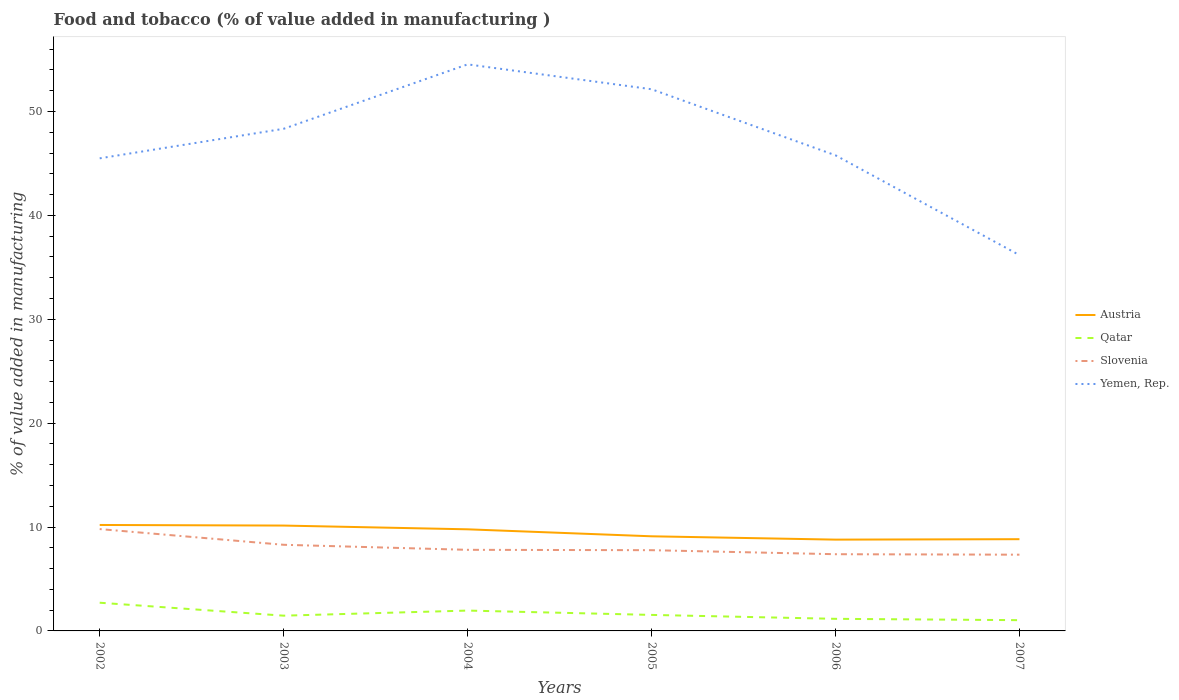How many different coloured lines are there?
Ensure brevity in your answer.  4. Across all years, what is the maximum value added in manufacturing food and tobacco in Yemen, Rep.?
Your answer should be very brief. 36.17. In which year was the value added in manufacturing food and tobacco in Austria maximum?
Make the answer very short. 2006. What is the total value added in manufacturing food and tobacco in Qatar in the graph?
Your response must be concise. 0.51. What is the difference between the highest and the second highest value added in manufacturing food and tobacco in Yemen, Rep.?
Provide a succinct answer. 18.36. Does the graph contain any zero values?
Your answer should be very brief. No. Does the graph contain grids?
Offer a terse response. No. How many legend labels are there?
Your response must be concise. 4. How are the legend labels stacked?
Keep it short and to the point. Vertical. What is the title of the graph?
Give a very brief answer. Food and tobacco (% of value added in manufacturing ). What is the label or title of the Y-axis?
Your answer should be compact. % of value added in manufacturing. What is the % of value added in manufacturing in Austria in 2002?
Offer a very short reply. 10.2. What is the % of value added in manufacturing in Qatar in 2002?
Provide a short and direct response. 2.71. What is the % of value added in manufacturing of Slovenia in 2002?
Make the answer very short. 9.8. What is the % of value added in manufacturing in Yemen, Rep. in 2002?
Ensure brevity in your answer.  45.49. What is the % of value added in manufacturing of Austria in 2003?
Your response must be concise. 10.14. What is the % of value added in manufacturing in Qatar in 2003?
Give a very brief answer. 1.47. What is the % of value added in manufacturing of Slovenia in 2003?
Offer a very short reply. 8.29. What is the % of value added in manufacturing of Yemen, Rep. in 2003?
Make the answer very short. 48.33. What is the % of value added in manufacturing of Austria in 2004?
Provide a short and direct response. 9.78. What is the % of value added in manufacturing of Qatar in 2004?
Keep it short and to the point. 1.96. What is the % of value added in manufacturing of Slovenia in 2004?
Ensure brevity in your answer.  7.81. What is the % of value added in manufacturing in Yemen, Rep. in 2004?
Provide a short and direct response. 54.53. What is the % of value added in manufacturing in Austria in 2005?
Make the answer very short. 9.11. What is the % of value added in manufacturing of Qatar in 2005?
Ensure brevity in your answer.  1.54. What is the % of value added in manufacturing of Slovenia in 2005?
Offer a terse response. 7.77. What is the % of value added in manufacturing in Yemen, Rep. in 2005?
Give a very brief answer. 52.14. What is the % of value added in manufacturing in Austria in 2006?
Your response must be concise. 8.79. What is the % of value added in manufacturing in Qatar in 2006?
Your response must be concise. 1.16. What is the % of value added in manufacturing of Slovenia in 2006?
Provide a short and direct response. 7.38. What is the % of value added in manufacturing of Yemen, Rep. in 2006?
Offer a very short reply. 45.78. What is the % of value added in manufacturing in Austria in 2007?
Give a very brief answer. 8.83. What is the % of value added in manufacturing of Qatar in 2007?
Ensure brevity in your answer.  1.04. What is the % of value added in manufacturing in Slovenia in 2007?
Give a very brief answer. 7.34. What is the % of value added in manufacturing in Yemen, Rep. in 2007?
Make the answer very short. 36.17. Across all years, what is the maximum % of value added in manufacturing in Austria?
Keep it short and to the point. 10.2. Across all years, what is the maximum % of value added in manufacturing of Qatar?
Offer a terse response. 2.71. Across all years, what is the maximum % of value added in manufacturing in Slovenia?
Your response must be concise. 9.8. Across all years, what is the maximum % of value added in manufacturing of Yemen, Rep.?
Provide a short and direct response. 54.53. Across all years, what is the minimum % of value added in manufacturing of Austria?
Your response must be concise. 8.79. Across all years, what is the minimum % of value added in manufacturing of Qatar?
Give a very brief answer. 1.04. Across all years, what is the minimum % of value added in manufacturing in Slovenia?
Your answer should be very brief. 7.34. Across all years, what is the minimum % of value added in manufacturing in Yemen, Rep.?
Provide a succinct answer. 36.17. What is the total % of value added in manufacturing in Austria in the graph?
Your response must be concise. 56.85. What is the total % of value added in manufacturing of Qatar in the graph?
Your answer should be compact. 9.88. What is the total % of value added in manufacturing of Slovenia in the graph?
Provide a succinct answer. 48.39. What is the total % of value added in manufacturing of Yemen, Rep. in the graph?
Offer a terse response. 282.45. What is the difference between the % of value added in manufacturing of Austria in 2002 and that in 2003?
Ensure brevity in your answer.  0.06. What is the difference between the % of value added in manufacturing of Qatar in 2002 and that in 2003?
Offer a very short reply. 1.25. What is the difference between the % of value added in manufacturing of Slovenia in 2002 and that in 2003?
Give a very brief answer. 1.51. What is the difference between the % of value added in manufacturing of Yemen, Rep. in 2002 and that in 2003?
Ensure brevity in your answer.  -2.84. What is the difference between the % of value added in manufacturing in Austria in 2002 and that in 2004?
Your answer should be compact. 0.42. What is the difference between the % of value added in manufacturing of Qatar in 2002 and that in 2004?
Offer a very short reply. 0.76. What is the difference between the % of value added in manufacturing of Slovenia in 2002 and that in 2004?
Provide a succinct answer. 2. What is the difference between the % of value added in manufacturing in Yemen, Rep. in 2002 and that in 2004?
Give a very brief answer. -9.04. What is the difference between the % of value added in manufacturing in Austria in 2002 and that in 2005?
Your answer should be compact. 1.09. What is the difference between the % of value added in manufacturing in Qatar in 2002 and that in 2005?
Offer a terse response. 1.17. What is the difference between the % of value added in manufacturing of Slovenia in 2002 and that in 2005?
Your answer should be very brief. 2.03. What is the difference between the % of value added in manufacturing of Yemen, Rep. in 2002 and that in 2005?
Your answer should be compact. -6.65. What is the difference between the % of value added in manufacturing in Austria in 2002 and that in 2006?
Provide a succinct answer. 1.41. What is the difference between the % of value added in manufacturing in Qatar in 2002 and that in 2006?
Ensure brevity in your answer.  1.55. What is the difference between the % of value added in manufacturing of Slovenia in 2002 and that in 2006?
Your answer should be very brief. 2.42. What is the difference between the % of value added in manufacturing of Yemen, Rep. in 2002 and that in 2006?
Provide a succinct answer. -0.29. What is the difference between the % of value added in manufacturing in Austria in 2002 and that in 2007?
Keep it short and to the point. 1.37. What is the difference between the % of value added in manufacturing in Qatar in 2002 and that in 2007?
Your answer should be compact. 1.68. What is the difference between the % of value added in manufacturing in Slovenia in 2002 and that in 2007?
Keep it short and to the point. 2.46. What is the difference between the % of value added in manufacturing in Yemen, Rep. in 2002 and that in 2007?
Your answer should be very brief. 9.32. What is the difference between the % of value added in manufacturing of Austria in 2003 and that in 2004?
Provide a succinct answer. 0.36. What is the difference between the % of value added in manufacturing of Qatar in 2003 and that in 2004?
Keep it short and to the point. -0.49. What is the difference between the % of value added in manufacturing of Slovenia in 2003 and that in 2004?
Ensure brevity in your answer.  0.48. What is the difference between the % of value added in manufacturing in Yemen, Rep. in 2003 and that in 2004?
Your answer should be very brief. -6.2. What is the difference between the % of value added in manufacturing of Austria in 2003 and that in 2005?
Your answer should be compact. 1.03. What is the difference between the % of value added in manufacturing of Qatar in 2003 and that in 2005?
Ensure brevity in your answer.  -0.07. What is the difference between the % of value added in manufacturing of Slovenia in 2003 and that in 2005?
Provide a short and direct response. 0.52. What is the difference between the % of value added in manufacturing in Yemen, Rep. in 2003 and that in 2005?
Provide a short and direct response. -3.81. What is the difference between the % of value added in manufacturing in Austria in 2003 and that in 2006?
Give a very brief answer. 1.35. What is the difference between the % of value added in manufacturing in Qatar in 2003 and that in 2006?
Your response must be concise. 0.3. What is the difference between the % of value added in manufacturing of Slovenia in 2003 and that in 2006?
Give a very brief answer. 0.91. What is the difference between the % of value added in manufacturing of Yemen, Rep. in 2003 and that in 2006?
Provide a short and direct response. 2.55. What is the difference between the % of value added in manufacturing in Austria in 2003 and that in 2007?
Provide a succinct answer. 1.31. What is the difference between the % of value added in manufacturing in Qatar in 2003 and that in 2007?
Your response must be concise. 0.43. What is the difference between the % of value added in manufacturing of Slovenia in 2003 and that in 2007?
Offer a very short reply. 0.95. What is the difference between the % of value added in manufacturing in Yemen, Rep. in 2003 and that in 2007?
Your response must be concise. 12.16. What is the difference between the % of value added in manufacturing of Austria in 2004 and that in 2005?
Keep it short and to the point. 0.67. What is the difference between the % of value added in manufacturing in Qatar in 2004 and that in 2005?
Make the answer very short. 0.42. What is the difference between the % of value added in manufacturing in Slovenia in 2004 and that in 2005?
Provide a short and direct response. 0.03. What is the difference between the % of value added in manufacturing in Yemen, Rep. in 2004 and that in 2005?
Your answer should be very brief. 2.39. What is the difference between the % of value added in manufacturing in Austria in 2004 and that in 2006?
Your answer should be compact. 0.99. What is the difference between the % of value added in manufacturing in Qatar in 2004 and that in 2006?
Make the answer very short. 0.79. What is the difference between the % of value added in manufacturing of Slovenia in 2004 and that in 2006?
Provide a succinct answer. 0.42. What is the difference between the % of value added in manufacturing in Yemen, Rep. in 2004 and that in 2006?
Ensure brevity in your answer.  8.75. What is the difference between the % of value added in manufacturing in Austria in 2004 and that in 2007?
Your answer should be compact. 0.95. What is the difference between the % of value added in manufacturing in Qatar in 2004 and that in 2007?
Offer a very short reply. 0.92. What is the difference between the % of value added in manufacturing of Slovenia in 2004 and that in 2007?
Your answer should be very brief. 0.47. What is the difference between the % of value added in manufacturing in Yemen, Rep. in 2004 and that in 2007?
Your answer should be very brief. 18.36. What is the difference between the % of value added in manufacturing in Austria in 2005 and that in 2006?
Your response must be concise. 0.32. What is the difference between the % of value added in manufacturing of Qatar in 2005 and that in 2006?
Offer a very short reply. 0.38. What is the difference between the % of value added in manufacturing in Slovenia in 2005 and that in 2006?
Your response must be concise. 0.39. What is the difference between the % of value added in manufacturing of Yemen, Rep. in 2005 and that in 2006?
Make the answer very short. 6.36. What is the difference between the % of value added in manufacturing of Austria in 2005 and that in 2007?
Keep it short and to the point. 0.28. What is the difference between the % of value added in manufacturing in Qatar in 2005 and that in 2007?
Your answer should be very brief. 0.51. What is the difference between the % of value added in manufacturing of Slovenia in 2005 and that in 2007?
Give a very brief answer. 0.43. What is the difference between the % of value added in manufacturing in Yemen, Rep. in 2005 and that in 2007?
Ensure brevity in your answer.  15.97. What is the difference between the % of value added in manufacturing of Austria in 2006 and that in 2007?
Offer a terse response. -0.04. What is the difference between the % of value added in manufacturing of Qatar in 2006 and that in 2007?
Your answer should be compact. 0.13. What is the difference between the % of value added in manufacturing in Slovenia in 2006 and that in 2007?
Keep it short and to the point. 0.05. What is the difference between the % of value added in manufacturing in Yemen, Rep. in 2006 and that in 2007?
Keep it short and to the point. 9.61. What is the difference between the % of value added in manufacturing in Austria in 2002 and the % of value added in manufacturing in Qatar in 2003?
Ensure brevity in your answer.  8.73. What is the difference between the % of value added in manufacturing in Austria in 2002 and the % of value added in manufacturing in Slovenia in 2003?
Your response must be concise. 1.91. What is the difference between the % of value added in manufacturing of Austria in 2002 and the % of value added in manufacturing of Yemen, Rep. in 2003?
Provide a short and direct response. -38.14. What is the difference between the % of value added in manufacturing of Qatar in 2002 and the % of value added in manufacturing of Slovenia in 2003?
Your answer should be very brief. -5.58. What is the difference between the % of value added in manufacturing of Qatar in 2002 and the % of value added in manufacturing of Yemen, Rep. in 2003?
Offer a terse response. -45.62. What is the difference between the % of value added in manufacturing of Slovenia in 2002 and the % of value added in manufacturing of Yemen, Rep. in 2003?
Give a very brief answer. -38.53. What is the difference between the % of value added in manufacturing in Austria in 2002 and the % of value added in manufacturing in Qatar in 2004?
Provide a short and direct response. 8.24. What is the difference between the % of value added in manufacturing in Austria in 2002 and the % of value added in manufacturing in Slovenia in 2004?
Your answer should be very brief. 2.39. What is the difference between the % of value added in manufacturing of Austria in 2002 and the % of value added in manufacturing of Yemen, Rep. in 2004?
Provide a short and direct response. -44.34. What is the difference between the % of value added in manufacturing of Qatar in 2002 and the % of value added in manufacturing of Slovenia in 2004?
Offer a very short reply. -5.09. What is the difference between the % of value added in manufacturing of Qatar in 2002 and the % of value added in manufacturing of Yemen, Rep. in 2004?
Provide a short and direct response. -51.82. What is the difference between the % of value added in manufacturing in Slovenia in 2002 and the % of value added in manufacturing in Yemen, Rep. in 2004?
Provide a succinct answer. -44.73. What is the difference between the % of value added in manufacturing in Austria in 2002 and the % of value added in manufacturing in Qatar in 2005?
Your answer should be compact. 8.66. What is the difference between the % of value added in manufacturing in Austria in 2002 and the % of value added in manufacturing in Slovenia in 2005?
Offer a terse response. 2.43. What is the difference between the % of value added in manufacturing of Austria in 2002 and the % of value added in manufacturing of Yemen, Rep. in 2005?
Offer a very short reply. -41.94. What is the difference between the % of value added in manufacturing of Qatar in 2002 and the % of value added in manufacturing of Slovenia in 2005?
Offer a terse response. -5.06. What is the difference between the % of value added in manufacturing of Qatar in 2002 and the % of value added in manufacturing of Yemen, Rep. in 2005?
Give a very brief answer. -49.43. What is the difference between the % of value added in manufacturing of Slovenia in 2002 and the % of value added in manufacturing of Yemen, Rep. in 2005?
Ensure brevity in your answer.  -42.34. What is the difference between the % of value added in manufacturing in Austria in 2002 and the % of value added in manufacturing in Qatar in 2006?
Your answer should be compact. 9.03. What is the difference between the % of value added in manufacturing in Austria in 2002 and the % of value added in manufacturing in Slovenia in 2006?
Offer a very short reply. 2.81. What is the difference between the % of value added in manufacturing in Austria in 2002 and the % of value added in manufacturing in Yemen, Rep. in 2006?
Provide a short and direct response. -35.58. What is the difference between the % of value added in manufacturing in Qatar in 2002 and the % of value added in manufacturing in Slovenia in 2006?
Keep it short and to the point. -4.67. What is the difference between the % of value added in manufacturing of Qatar in 2002 and the % of value added in manufacturing of Yemen, Rep. in 2006?
Your response must be concise. -43.07. What is the difference between the % of value added in manufacturing in Slovenia in 2002 and the % of value added in manufacturing in Yemen, Rep. in 2006?
Provide a short and direct response. -35.98. What is the difference between the % of value added in manufacturing in Austria in 2002 and the % of value added in manufacturing in Qatar in 2007?
Keep it short and to the point. 9.16. What is the difference between the % of value added in manufacturing of Austria in 2002 and the % of value added in manufacturing of Slovenia in 2007?
Provide a succinct answer. 2.86. What is the difference between the % of value added in manufacturing in Austria in 2002 and the % of value added in manufacturing in Yemen, Rep. in 2007?
Ensure brevity in your answer.  -25.98. What is the difference between the % of value added in manufacturing in Qatar in 2002 and the % of value added in manufacturing in Slovenia in 2007?
Your response must be concise. -4.62. What is the difference between the % of value added in manufacturing in Qatar in 2002 and the % of value added in manufacturing in Yemen, Rep. in 2007?
Ensure brevity in your answer.  -33.46. What is the difference between the % of value added in manufacturing of Slovenia in 2002 and the % of value added in manufacturing of Yemen, Rep. in 2007?
Your answer should be compact. -26.37. What is the difference between the % of value added in manufacturing in Austria in 2003 and the % of value added in manufacturing in Qatar in 2004?
Make the answer very short. 8.18. What is the difference between the % of value added in manufacturing in Austria in 2003 and the % of value added in manufacturing in Slovenia in 2004?
Give a very brief answer. 2.33. What is the difference between the % of value added in manufacturing in Austria in 2003 and the % of value added in manufacturing in Yemen, Rep. in 2004?
Keep it short and to the point. -44.39. What is the difference between the % of value added in manufacturing of Qatar in 2003 and the % of value added in manufacturing of Slovenia in 2004?
Give a very brief answer. -6.34. What is the difference between the % of value added in manufacturing of Qatar in 2003 and the % of value added in manufacturing of Yemen, Rep. in 2004?
Your answer should be very brief. -53.07. What is the difference between the % of value added in manufacturing of Slovenia in 2003 and the % of value added in manufacturing of Yemen, Rep. in 2004?
Your answer should be compact. -46.24. What is the difference between the % of value added in manufacturing in Austria in 2003 and the % of value added in manufacturing in Qatar in 2005?
Provide a succinct answer. 8.6. What is the difference between the % of value added in manufacturing in Austria in 2003 and the % of value added in manufacturing in Slovenia in 2005?
Your answer should be very brief. 2.37. What is the difference between the % of value added in manufacturing of Austria in 2003 and the % of value added in manufacturing of Yemen, Rep. in 2005?
Give a very brief answer. -42. What is the difference between the % of value added in manufacturing in Qatar in 2003 and the % of value added in manufacturing in Slovenia in 2005?
Make the answer very short. -6.3. What is the difference between the % of value added in manufacturing of Qatar in 2003 and the % of value added in manufacturing of Yemen, Rep. in 2005?
Offer a terse response. -50.67. What is the difference between the % of value added in manufacturing in Slovenia in 2003 and the % of value added in manufacturing in Yemen, Rep. in 2005?
Make the answer very short. -43.85. What is the difference between the % of value added in manufacturing of Austria in 2003 and the % of value added in manufacturing of Qatar in 2006?
Your answer should be compact. 8.98. What is the difference between the % of value added in manufacturing in Austria in 2003 and the % of value added in manufacturing in Slovenia in 2006?
Keep it short and to the point. 2.76. What is the difference between the % of value added in manufacturing in Austria in 2003 and the % of value added in manufacturing in Yemen, Rep. in 2006?
Provide a short and direct response. -35.64. What is the difference between the % of value added in manufacturing in Qatar in 2003 and the % of value added in manufacturing in Slovenia in 2006?
Give a very brief answer. -5.92. What is the difference between the % of value added in manufacturing of Qatar in 2003 and the % of value added in manufacturing of Yemen, Rep. in 2006?
Your answer should be compact. -44.31. What is the difference between the % of value added in manufacturing in Slovenia in 2003 and the % of value added in manufacturing in Yemen, Rep. in 2006?
Keep it short and to the point. -37.49. What is the difference between the % of value added in manufacturing of Austria in 2003 and the % of value added in manufacturing of Qatar in 2007?
Offer a terse response. 9.11. What is the difference between the % of value added in manufacturing in Austria in 2003 and the % of value added in manufacturing in Slovenia in 2007?
Your response must be concise. 2.8. What is the difference between the % of value added in manufacturing of Austria in 2003 and the % of value added in manufacturing of Yemen, Rep. in 2007?
Your answer should be compact. -26.03. What is the difference between the % of value added in manufacturing in Qatar in 2003 and the % of value added in manufacturing in Slovenia in 2007?
Provide a succinct answer. -5.87. What is the difference between the % of value added in manufacturing of Qatar in 2003 and the % of value added in manufacturing of Yemen, Rep. in 2007?
Your answer should be very brief. -34.71. What is the difference between the % of value added in manufacturing of Slovenia in 2003 and the % of value added in manufacturing of Yemen, Rep. in 2007?
Your answer should be compact. -27.88. What is the difference between the % of value added in manufacturing in Austria in 2004 and the % of value added in manufacturing in Qatar in 2005?
Give a very brief answer. 8.24. What is the difference between the % of value added in manufacturing of Austria in 2004 and the % of value added in manufacturing of Slovenia in 2005?
Keep it short and to the point. 2.01. What is the difference between the % of value added in manufacturing of Austria in 2004 and the % of value added in manufacturing of Yemen, Rep. in 2005?
Offer a terse response. -42.36. What is the difference between the % of value added in manufacturing in Qatar in 2004 and the % of value added in manufacturing in Slovenia in 2005?
Your response must be concise. -5.81. What is the difference between the % of value added in manufacturing in Qatar in 2004 and the % of value added in manufacturing in Yemen, Rep. in 2005?
Ensure brevity in your answer.  -50.18. What is the difference between the % of value added in manufacturing of Slovenia in 2004 and the % of value added in manufacturing of Yemen, Rep. in 2005?
Provide a succinct answer. -44.33. What is the difference between the % of value added in manufacturing of Austria in 2004 and the % of value added in manufacturing of Qatar in 2006?
Your answer should be compact. 8.62. What is the difference between the % of value added in manufacturing of Austria in 2004 and the % of value added in manufacturing of Slovenia in 2006?
Offer a terse response. 2.4. What is the difference between the % of value added in manufacturing in Austria in 2004 and the % of value added in manufacturing in Yemen, Rep. in 2006?
Your answer should be compact. -36. What is the difference between the % of value added in manufacturing of Qatar in 2004 and the % of value added in manufacturing of Slovenia in 2006?
Your response must be concise. -5.43. What is the difference between the % of value added in manufacturing in Qatar in 2004 and the % of value added in manufacturing in Yemen, Rep. in 2006?
Give a very brief answer. -43.82. What is the difference between the % of value added in manufacturing of Slovenia in 2004 and the % of value added in manufacturing of Yemen, Rep. in 2006?
Your response must be concise. -37.98. What is the difference between the % of value added in manufacturing in Austria in 2004 and the % of value added in manufacturing in Qatar in 2007?
Your answer should be compact. 8.75. What is the difference between the % of value added in manufacturing in Austria in 2004 and the % of value added in manufacturing in Slovenia in 2007?
Your answer should be compact. 2.44. What is the difference between the % of value added in manufacturing of Austria in 2004 and the % of value added in manufacturing of Yemen, Rep. in 2007?
Provide a succinct answer. -26.39. What is the difference between the % of value added in manufacturing in Qatar in 2004 and the % of value added in manufacturing in Slovenia in 2007?
Provide a succinct answer. -5.38. What is the difference between the % of value added in manufacturing of Qatar in 2004 and the % of value added in manufacturing of Yemen, Rep. in 2007?
Provide a short and direct response. -34.22. What is the difference between the % of value added in manufacturing in Slovenia in 2004 and the % of value added in manufacturing in Yemen, Rep. in 2007?
Your answer should be very brief. -28.37. What is the difference between the % of value added in manufacturing of Austria in 2005 and the % of value added in manufacturing of Qatar in 2006?
Make the answer very short. 7.94. What is the difference between the % of value added in manufacturing of Austria in 2005 and the % of value added in manufacturing of Slovenia in 2006?
Your answer should be very brief. 1.72. What is the difference between the % of value added in manufacturing in Austria in 2005 and the % of value added in manufacturing in Yemen, Rep. in 2006?
Give a very brief answer. -36.67. What is the difference between the % of value added in manufacturing in Qatar in 2005 and the % of value added in manufacturing in Slovenia in 2006?
Provide a succinct answer. -5.84. What is the difference between the % of value added in manufacturing of Qatar in 2005 and the % of value added in manufacturing of Yemen, Rep. in 2006?
Your answer should be very brief. -44.24. What is the difference between the % of value added in manufacturing of Slovenia in 2005 and the % of value added in manufacturing of Yemen, Rep. in 2006?
Your answer should be compact. -38.01. What is the difference between the % of value added in manufacturing in Austria in 2005 and the % of value added in manufacturing in Qatar in 2007?
Ensure brevity in your answer.  8.07. What is the difference between the % of value added in manufacturing of Austria in 2005 and the % of value added in manufacturing of Slovenia in 2007?
Provide a succinct answer. 1.77. What is the difference between the % of value added in manufacturing of Austria in 2005 and the % of value added in manufacturing of Yemen, Rep. in 2007?
Give a very brief answer. -27.07. What is the difference between the % of value added in manufacturing of Qatar in 2005 and the % of value added in manufacturing of Slovenia in 2007?
Offer a terse response. -5.8. What is the difference between the % of value added in manufacturing of Qatar in 2005 and the % of value added in manufacturing of Yemen, Rep. in 2007?
Make the answer very short. -34.63. What is the difference between the % of value added in manufacturing of Slovenia in 2005 and the % of value added in manufacturing of Yemen, Rep. in 2007?
Ensure brevity in your answer.  -28.4. What is the difference between the % of value added in manufacturing of Austria in 2006 and the % of value added in manufacturing of Qatar in 2007?
Your answer should be very brief. 7.75. What is the difference between the % of value added in manufacturing of Austria in 2006 and the % of value added in manufacturing of Slovenia in 2007?
Make the answer very short. 1.45. What is the difference between the % of value added in manufacturing in Austria in 2006 and the % of value added in manufacturing in Yemen, Rep. in 2007?
Provide a succinct answer. -27.39. What is the difference between the % of value added in manufacturing of Qatar in 2006 and the % of value added in manufacturing of Slovenia in 2007?
Ensure brevity in your answer.  -6.17. What is the difference between the % of value added in manufacturing in Qatar in 2006 and the % of value added in manufacturing in Yemen, Rep. in 2007?
Keep it short and to the point. -35.01. What is the difference between the % of value added in manufacturing of Slovenia in 2006 and the % of value added in manufacturing of Yemen, Rep. in 2007?
Offer a very short reply. -28.79. What is the average % of value added in manufacturing in Austria per year?
Offer a very short reply. 9.47. What is the average % of value added in manufacturing of Qatar per year?
Provide a succinct answer. 1.65. What is the average % of value added in manufacturing of Slovenia per year?
Keep it short and to the point. 8.07. What is the average % of value added in manufacturing of Yemen, Rep. per year?
Your answer should be compact. 47.08. In the year 2002, what is the difference between the % of value added in manufacturing in Austria and % of value added in manufacturing in Qatar?
Give a very brief answer. 7.48. In the year 2002, what is the difference between the % of value added in manufacturing of Austria and % of value added in manufacturing of Slovenia?
Offer a terse response. 0.39. In the year 2002, what is the difference between the % of value added in manufacturing of Austria and % of value added in manufacturing of Yemen, Rep.?
Give a very brief answer. -35.29. In the year 2002, what is the difference between the % of value added in manufacturing of Qatar and % of value added in manufacturing of Slovenia?
Offer a terse response. -7.09. In the year 2002, what is the difference between the % of value added in manufacturing of Qatar and % of value added in manufacturing of Yemen, Rep.?
Keep it short and to the point. -42.78. In the year 2002, what is the difference between the % of value added in manufacturing of Slovenia and % of value added in manufacturing of Yemen, Rep.?
Make the answer very short. -35.69. In the year 2003, what is the difference between the % of value added in manufacturing of Austria and % of value added in manufacturing of Qatar?
Keep it short and to the point. 8.67. In the year 2003, what is the difference between the % of value added in manufacturing in Austria and % of value added in manufacturing in Slovenia?
Offer a terse response. 1.85. In the year 2003, what is the difference between the % of value added in manufacturing in Austria and % of value added in manufacturing in Yemen, Rep.?
Your answer should be compact. -38.19. In the year 2003, what is the difference between the % of value added in manufacturing of Qatar and % of value added in manufacturing of Slovenia?
Your answer should be very brief. -6.82. In the year 2003, what is the difference between the % of value added in manufacturing of Qatar and % of value added in manufacturing of Yemen, Rep.?
Provide a succinct answer. -46.87. In the year 2003, what is the difference between the % of value added in manufacturing in Slovenia and % of value added in manufacturing in Yemen, Rep.?
Make the answer very short. -40.04. In the year 2004, what is the difference between the % of value added in manufacturing in Austria and % of value added in manufacturing in Qatar?
Your answer should be compact. 7.82. In the year 2004, what is the difference between the % of value added in manufacturing of Austria and % of value added in manufacturing of Slovenia?
Your answer should be compact. 1.97. In the year 2004, what is the difference between the % of value added in manufacturing of Austria and % of value added in manufacturing of Yemen, Rep.?
Provide a short and direct response. -44.75. In the year 2004, what is the difference between the % of value added in manufacturing in Qatar and % of value added in manufacturing in Slovenia?
Your answer should be compact. -5.85. In the year 2004, what is the difference between the % of value added in manufacturing of Qatar and % of value added in manufacturing of Yemen, Rep.?
Give a very brief answer. -52.58. In the year 2004, what is the difference between the % of value added in manufacturing of Slovenia and % of value added in manufacturing of Yemen, Rep.?
Provide a succinct answer. -46.73. In the year 2005, what is the difference between the % of value added in manufacturing of Austria and % of value added in manufacturing of Qatar?
Ensure brevity in your answer.  7.57. In the year 2005, what is the difference between the % of value added in manufacturing in Austria and % of value added in manufacturing in Slovenia?
Your response must be concise. 1.34. In the year 2005, what is the difference between the % of value added in manufacturing in Austria and % of value added in manufacturing in Yemen, Rep.?
Your answer should be compact. -43.03. In the year 2005, what is the difference between the % of value added in manufacturing in Qatar and % of value added in manufacturing in Slovenia?
Offer a terse response. -6.23. In the year 2005, what is the difference between the % of value added in manufacturing of Qatar and % of value added in manufacturing of Yemen, Rep.?
Offer a terse response. -50.6. In the year 2005, what is the difference between the % of value added in manufacturing of Slovenia and % of value added in manufacturing of Yemen, Rep.?
Offer a terse response. -44.37. In the year 2006, what is the difference between the % of value added in manufacturing of Austria and % of value added in manufacturing of Qatar?
Provide a short and direct response. 7.62. In the year 2006, what is the difference between the % of value added in manufacturing in Austria and % of value added in manufacturing in Slovenia?
Offer a very short reply. 1.4. In the year 2006, what is the difference between the % of value added in manufacturing of Austria and % of value added in manufacturing of Yemen, Rep.?
Provide a short and direct response. -36.99. In the year 2006, what is the difference between the % of value added in manufacturing of Qatar and % of value added in manufacturing of Slovenia?
Give a very brief answer. -6.22. In the year 2006, what is the difference between the % of value added in manufacturing of Qatar and % of value added in manufacturing of Yemen, Rep.?
Provide a short and direct response. -44.62. In the year 2006, what is the difference between the % of value added in manufacturing of Slovenia and % of value added in manufacturing of Yemen, Rep.?
Keep it short and to the point. -38.4. In the year 2007, what is the difference between the % of value added in manufacturing in Austria and % of value added in manufacturing in Qatar?
Keep it short and to the point. 7.8. In the year 2007, what is the difference between the % of value added in manufacturing of Austria and % of value added in manufacturing of Slovenia?
Ensure brevity in your answer.  1.49. In the year 2007, what is the difference between the % of value added in manufacturing of Austria and % of value added in manufacturing of Yemen, Rep.?
Make the answer very short. -27.34. In the year 2007, what is the difference between the % of value added in manufacturing in Qatar and % of value added in manufacturing in Slovenia?
Provide a succinct answer. -6.3. In the year 2007, what is the difference between the % of value added in manufacturing in Qatar and % of value added in manufacturing in Yemen, Rep.?
Ensure brevity in your answer.  -35.14. In the year 2007, what is the difference between the % of value added in manufacturing in Slovenia and % of value added in manufacturing in Yemen, Rep.?
Keep it short and to the point. -28.84. What is the ratio of the % of value added in manufacturing of Austria in 2002 to that in 2003?
Your answer should be compact. 1.01. What is the ratio of the % of value added in manufacturing of Qatar in 2002 to that in 2003?
Offer a terse response. 1.85. What is the ratio of the % of value added in manufacturing in Slovenia in 2002 to that in 2003?
Provide a succinct answer. 1.18. What is the ratio of the % of value added in manufacturing in Yemen, Rep. in 2002 to that in 2003?
Keep it short and to the point. 0.94. What is the ratio of the % of value added in manufacturing of Austria in 2002 to that in 2004?
Make the answer very short. 1.04. What is the ratio of the % of value added in manufacturing in Qatar in 2002 to that in 2004?
Ensure brevity in your answer.  1.39. What is the ratio of the % of value added in manufacturing of Slovenia in 2002 to that in 2004?
Offer a terse response. 1.26. What is the ratio of the % of value added in manufacturing in Yemen, Rep. in 2002 to that in 2004?
Offer a very short reply. 0.83. What is the ratio of the % of value added in manufacturing of Austria in 2002 to that in 2005?
Provide a succinct answer. 1.12. What is the ratio of the % of value added in manufacturing in Qatar in 2002 to that in 2005?
Your answer should be very brief. 1.76. What is the ratio of the % of value added in manufacturing of Slovenia in 2002 to that in 2005?
Your response must be concise. 1.26. What is the ratio of the % of value added in manufacturing in Yemen, Rep. in 2002 to that in 2005?
Make the answer very short. 0.87. What is the ratio of the % of value added in manufacturing in Austria in 2002 to that in 2006?
Give a very brief answer. 1.16. What is the ratio of the % of value added in manufacturing in Qatar in 2002 to that in 2006?
Your answer should be compact. 2.33. What is the ratio of the % of value added in manufacturing in Slovenia in 2002 to that in 2006?
Your answer should be very brief. 1.33. What is the ratio of the % of value added in manufacturing of Austria in 2002 to that in 2007?
Offer a terse response. 1.15. What is the ratio of the % of value added in manufacturing of Qatar in 2002 to that in 2007?
Your response must be concise. 2.62. What is the ratio of the % of value added in manufacturing in Slovenia in 2002 to that in 2007?
Your response must be concise. 1.34. What is the ratio of the % of value added in manufacturing in Yemen, Rep. in 2002 to that in 2007?
Your response must be concise. 1.26. What is the ratio of the % of value added in manufacturing in Austria in 2003 to that in 2004?
Offer a terse response. 1.04. What is the ratio of the % of value added in manufacturing of Qatar in 2003 to that in 2004?
Provide a succinct answer. 0.75. What is the ratio of the % of value added in manufacturing of Slovenia in 2003 to that in 2004?
Your answer should be very brief. 1.06. What is the ratio of the % of value added in manufacturing of Yemen, Rep. in 2003 to that in 2004?
Keep it short and to the point. 0.89. What is the ratio of the % of value added in manufacturing of Austria in 2003 to that in 2005?
Keep it short and to the point. 1.11. What is the ratio of the % of value added in manufacturing in Qatar in 2003 to that in 2005?
Provide a succinct answer. 0.95. What is the ratio of the % of value added in manufacturing in Slovenia in 2003 to that in 2005?
Give a very brief answer. 1.07. What is the ratio of the % of value added in manufacturing of Yemen, Rep. in 2003 to that in 2005?
Keep it short and to the point. 0.93. What is the ratio of the % of value added in manufacturing in Austria in 2003 to that in 2006?
Your answer should be very brief. 1.15. What is the ratio of the % of value added in manufacturing of Qatar in 2003 to that in 2006?
Give a very brief answer. 1.26. What is the ratio of the % of value added in manufacturing of Slovenia in 2003 to that in 2006?
Provide a short and direct response. 1.12. What is the ratio of the % of value added in manufacturing in Yemen, Rep. in 2003 to that in 2006?
Ensure brevity in your answer.  1.06. What is the ratio of the % of value added in manufacturing of Austria in 2003 to that in 2007?
Make the answer very short. 1.15. What is the ratio of the % of value added in manufacturing of Qatar in 2003 to that in 2007?
Give a very brief answer. 1.42. What is the ratio of the % of value added in manufacturing of Slovenia in 2003 to that in 2007?
Give a very brief answer. 1.13. What is the ratio of the % of value added in manufacturing of Yemen, Rep. in 2003 to that in 2007?
Offer a very short reply. 1.34. What is the ratio of the % of value added in manufacturing of Austria in 2004 to that in 2005?
Offer a very short reply. 1.07. What is the ratio of the % of value added in manufacturing in Qatar in 2004 to that in 2005?
Give a very brief answer. 1.27. What is the ratio of the % of value added in manufacturing of Yemen, Rep. in 2004 to that in 2005?
Provide a succinct answer. 1.05. What is the ratio of the % of value added in manufacturing in Austria in 2004 to that in 2006?
Keep it short and to the point. 1.11. What is the ratio of the % of value added in manufacturing in Qatar in 2004 to that in 2006?
Your answer should be very brief. 1.68. What is the ratio of the % of value added in manufacturing in Slovenia in 2004 to that in 2006?
Your answer should be very brief. 1.06. What is the ratio of the % of value added in manufacturing in Yemen, Rep. in 2004 to that in 2006?
Ensure brevity in your answer.  1.19. What is the ratio of the % of value added in manufacturing in Austria in 2004 to that in 2007?
Make the answer very short. 1.11. What is the ratio of the % of value added in manufacturing in Qatar in 2004 to that in 2007?
Your answer should be very brief. 1.89. What is the ratio of the % of value added in manufacturing in Slovenia in 2004 to that in 2007?
Your answer should be very brief. 1.06. What is the ratio of the % of value added in manufacturing of Yemen, Rep. in 2004 to that in 2007?
Offer a very short reply. 1.51. What is the ratio of the % of value added in manufacturing in Austria in 2005 to that in 2006?
Keep it short and to the point. 1.04. What is the ratio of the % of value added in manufacturing of Qatar in 2005 to that in 2006?
Offer a very short reply. 1.32. What is the ratio of the % of value added in manufacturing of Slovenia in 2005 to that in 2006?
Your answer should be compact. 1.05. What is the ratio of the % of value added in manufacturing of Yemen, Rep. in 2005 to that in 2006?
Make the answer very short. 1.14. What is the ratio of the % of value added in manufacturing in Austria in 2005 to that in 2007?
Make the answer very short. 1.03. What is the ratio of the % of value added in manufacturing in Qatar in 2005 to that in 2007?
Provide a short and direct response. 1.49. What is the ratio of the % of value added in manufacturing in Slovenia in 2005 to that in 2007?
Provide a short and direct response. 1.06. What is the ratio of the % of value added in manufacturing in Yemen, Rep. in 2005 to that in 2007?
Keep it short and to the point. 1.44. What is the ratio of the % of value added in manufacturing of Austria in 2006 to that in 2007?
Offer a terse response. 1. What is the ratio of the % of value added in manufacturing of Qatar in 2006 to that in 2007?
Make the answer very short. 1.12. What is the ratio of the % of value added in manufacturing of Yemen, Rep. in 2006 to that in 2007?
Offer a very short reply. 1.27. What is the difference between the highest and the second highest % of value added in manufacturing of Austria?
Your answer should be very brief. 0.06. What is the difference between the highest and the second highest % of value added in manufacturing of Qatar?
Give a very brief answer. 0.76. What is the difference between the highest and the second highest % of value added in manufacturing in Slovenia?
Offer a very short reply. 1.51. What is the difference between the highest and the second highest % of value added in manufacturing in Yemen, Rep.?
Provide a succinct answer. 2.39. What is the difference between the highest and the lowest % of value added in manufacturing in Austria?
Make the answer very short. 1.41. What is the difference between the highest and the lowest % of value added in manufacturing in Qatar?
Offer a terse response. 1.68. What is the difference between the highest and the lowest % of value added in manufacturing of Slovenia?
Your answer should be very brief. 2.46. What is the difference between the highest and the lowest % of value added in manufacturing of Yemen, Rep.?
Ensure brevity in your answer.  18.36. 